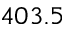<formula> <loc_0><loc_0><loc_500><loc_500>4 0 3 . 5</formula> 